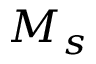Convert formula to latex. <formula><loc_0><loc_0><loc_500><loc_500>M _ { s }</formula> 